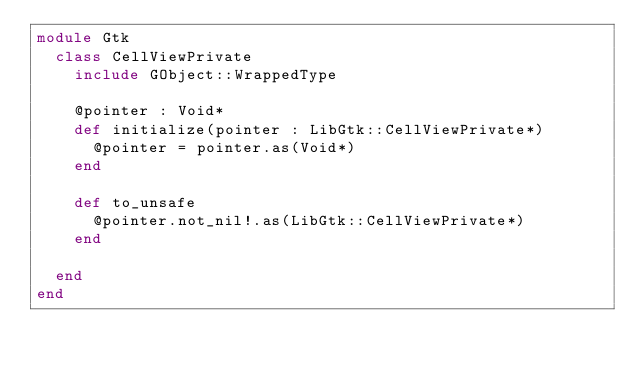Convert code to text. <code><loc_0><loc_0><loc_500><loc_500><_Crystal_>module Gtk
  class CellViewPrivate
    include GObject::WrappedType

    @pointer : Void*
    def initialize(pointer : LibGtk::CellViewPrivate*)
      @pointer = pointer.as(Void*)
    end

    def to_unsafe
      @pointer.not_nil!.as(LibGtk::CellViewPrivate*)
    end

  end
end

</code> 